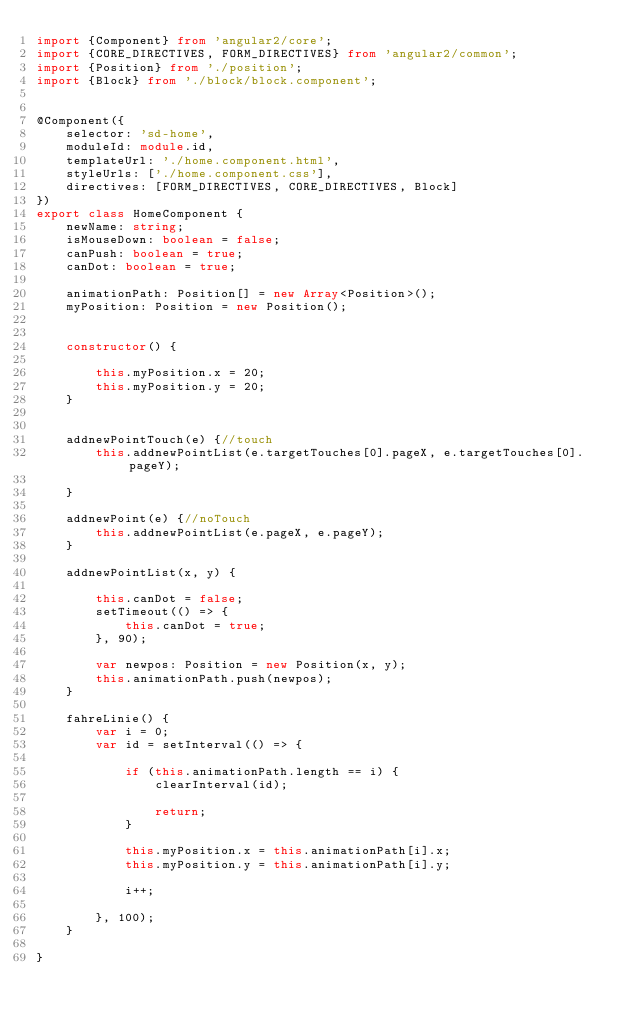<code> <loc_0><loc_0><loc_500><loc_500><_TypeScript_>import {Component} from 'angular2/core';
import {CORE_DIRECTIVES, FORM_DIRECTIVES} from 'angular2/common';
import {Position} from './position';
import {Block} from './block/block.component';


@Component({
    selector: 'sd-home',
    moduleId: module.id,
    templateUrl: './home.component.html',
    styleUrls: ['./home.component.css'],
    directives: [FORM_DIRECTIVES, CORE_DIRECTIVES, Block]
})
export class HomeComponent {
    newName: string;
    isMouseDown: boolean = false;
    canPush: boolean = true;
    canDot: boolean = true;

    animationPath: Position[] = new Array<Position>();
    myPosition: Position = new Position();


    constructor() {

        this.myPosition.x = 20;
        this.myPosition.y = 20;
    }


    addnewPointTouch(e) {//touch
        this.addnewPointList(e.targetTouches[0].pageX, e.targetTouches[0].pageY);

    }

    addnewPoint(e) {//noTouch
        this.addnewPointList(e.pageX, e.pageY);
    }

    addnewPointList(x, y) {

        this.canDot = false;
        setTimeout(() => {
            this.canDot = true;
        }, 90);

        var newpos: Position = new Position(x, y);
        this.animationPath.push(newpos);
    }

    fahreLinie() {
        var i = 0;
        var id = setInterval(() => {

            if (this.animationPath.length == i) {
                clearInterval(id);

                return;
            }

            this.myPosition.x = this.animationPath[i].x;
            this.myPosition.y = this.animationPath[i].y;

            i++;

        }, 100);
    }

}
</code> 